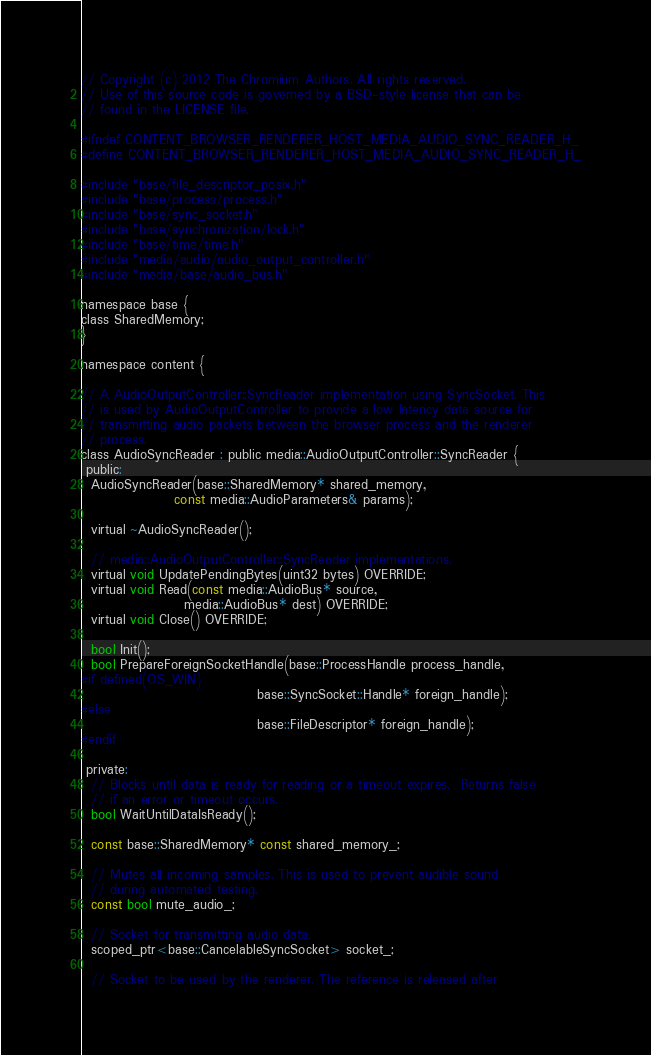<code> <loc_0><loc_0><loc_500><loc_500><_C_>// Copyright (c) 2012 The Chromium Authors. All rights reserved.
// Use of this source code is governed by a BSD-style license that can be
// found in the LICENSE file.

#ifndef CONTENT_BROWSER_RENDERER_HOST_MEDIA_AUDIO_SYNC_READER_H_
#define CONTENT_BROWSER_RENDERER_HOST_MEDIA_AUDIO_SYNC_READER_H_

#include "base/file_descriptor_posix.h"
#include "base/process/process.h"
#include "base/sync_socket.h"
#include "base/synchronization/lock.h"
#include "base/time/time.h"
#include "media/audio/audio_output_controller.h"
#include "media/base/audio_bus.h"

namespace base {
class SharedMemory;
}

namespace content {

// A AudioOutputController::SyncReader implementation using SyncSocket. This
// is used by AudioOutputController to provide a low latency data source for
// transmitting audio packets between the browser process and the renderer
// process.
class AudioSyncReader : public media::AudioOutputController::SyncReader {
 public:
  AudioSyncReader(base::SharedMemory* shared_memory,
                  const media::AudioParameters& params);

  virtual ~AudioSyncReader();

  // media::AudioOutputController::SyncReader implementations.
  virtual void UpdatePendingBytes(uint32 bytes) OVERRIDE;
  virtual void Read(const media::AudioBus* source,
                    media::AudioBus* dest) OVERRIDE;
  virtual void Close() OVERRIDE;

  bool Init();
  bool PrepareForeignSocketHandle(base::ProcessHandle process_handle,
#if defined(OS_WIN)
                                  base::SyncSocket::Handle* foreign_handle);
#else
                                  base::FileDescriptor* foreign_handle);
#endif

 private:
  // Blocks until data is ready for reading or a timeout expires.  Returns false
  // if an error or timeout occurs.
  bool WaitUntilDataIsReady();

  const base::SharedMemory* const shared_memory_;

  // Mutes all incoming samples. This is used to prevent audible sound
  // during automated testing.
  const bool mute_audio_;

  // Socket for transmitting audio data.
  scoped_ptr<base::CancelableSyncSocket> socket_;

  // Socket to be used by the renderer. The reference is released after</code> 